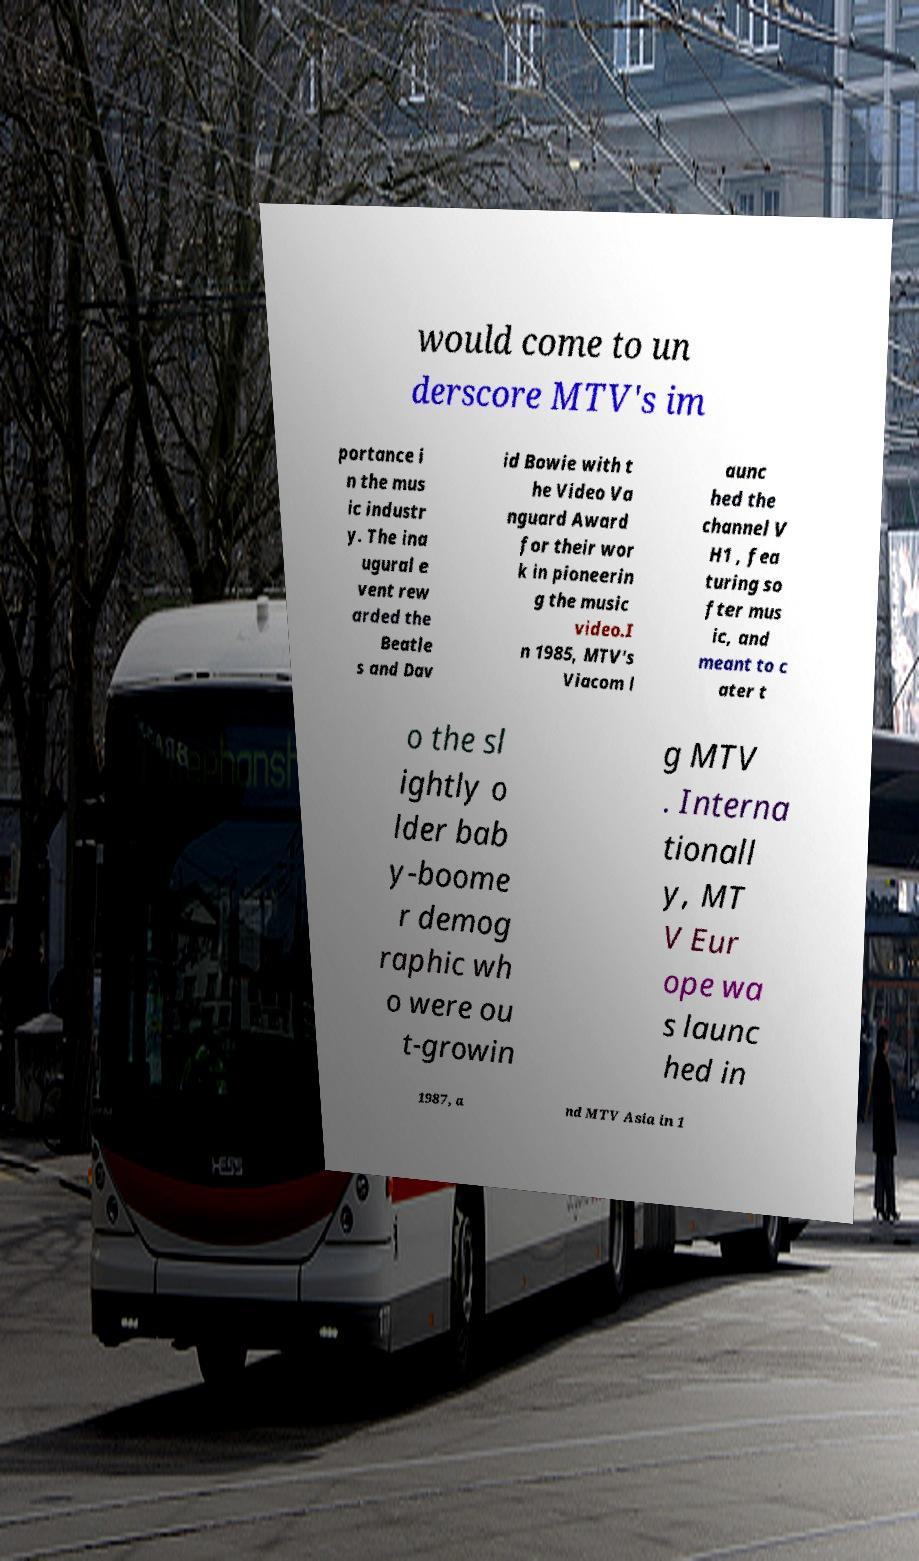Please read and relay the text visible in this image. What does it say? would come to un derscore MTV's im portance i n the mus ic industr y. The ina ugural e vent rew arded the Beatle s and Dav id Bowie with t he Video Va nguard Award for their wor k in pioneerin g the music video.I n 1985, MTV's Viacom l aunc hed the channel V H1 , fea turing so fter mus ic, and meant to c ater t o the sl ightly o lder bab y-boome r demog raphic wh o were ou t-growin g MTV . Interna tionall y, MT V Eur ope wa s launc hed in 1987, a nd MTV Asia in 1 